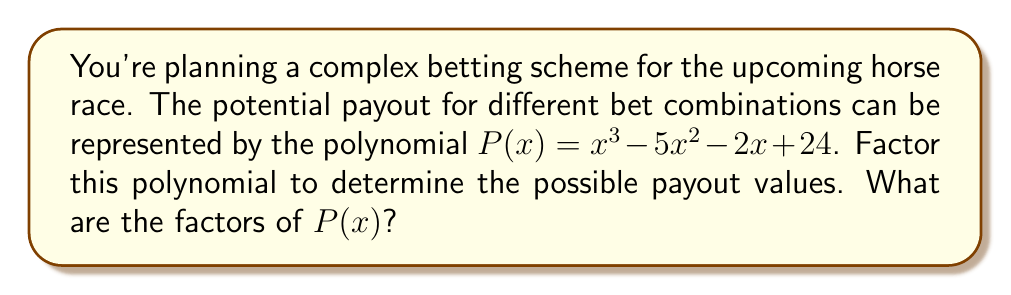Could you help me with this problem? To factor this polynomial, we'll follow these steps:

1) First, let's check if there are any rational roots using the rational root theorem. The possible rational roots are the factors of the constant term: $\pm 1, \pm 2, \pm 3, \pm 4, \pm 6, \pm 8, \pm 12, \pm 24$.

2) Testing these values, we find that $x = 4$ is a root. So $(x - 4)$ is a factor.

3) We can use polynomial long division to divide $P(x)$ by $(x - 4)$:

   $$\frac{x^3 - 5x^2 - 2x + 24}{x - 4} = x^2 - x - 6$$

4) Now we need to factor the quadratic $x^2 - x - 6$. We can do this by finding two numbers that multiply to give -6 and add to give -1. These numbers are -3 and 2.

5) So $x^2 - x - 6 = (x - 3)(x + 2)$

6) Putting it all together, we have:

   $$P(x) = (x - 4)(x - 3)(x + 2)$$

This factorization represents the different possible payout scenarios based on various bet combinations.
Answer: The factors of $P(x)$ are $(x - 4)$, $(x - 3)$, and $(x + 2)$. 